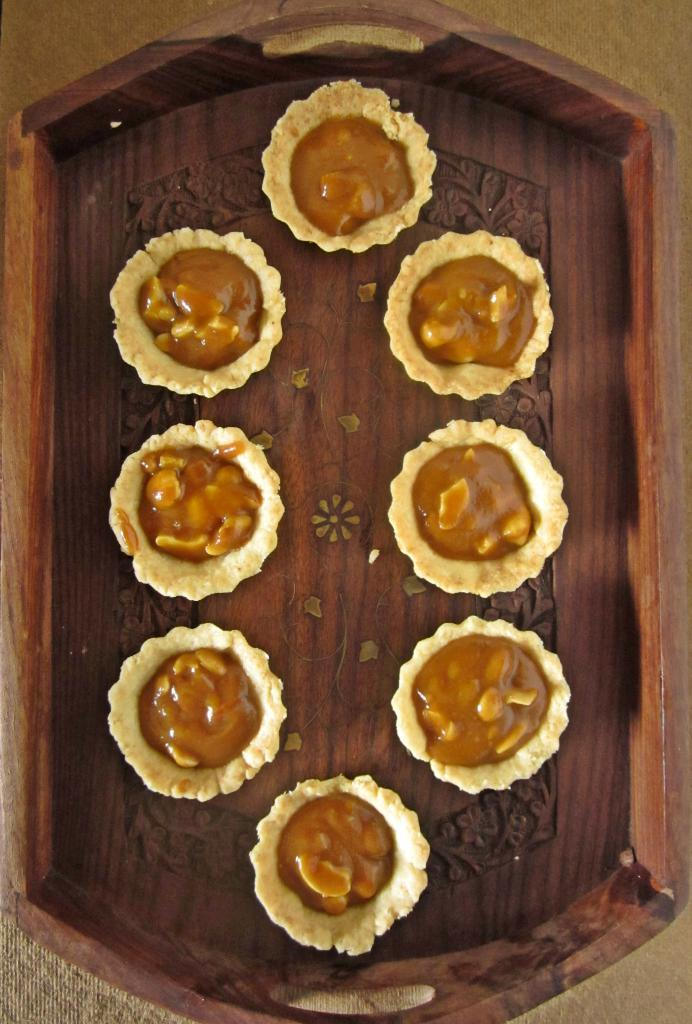What is on the wooden tray in the image? There are food items on a wooden tray in the image. Can you describe the surface on which the wooden tray is placed? The wooden tray is placed on a surface, but the specific type of surface is not mentioned in the facts. How many food items are on the wooden tray? The number of food items on the wooden tray is not mentioned in the facts. What type of garden can be seen in the background of the image? There is no garden present in the image; it only shows food items on a wooden tray placed on a surface. 